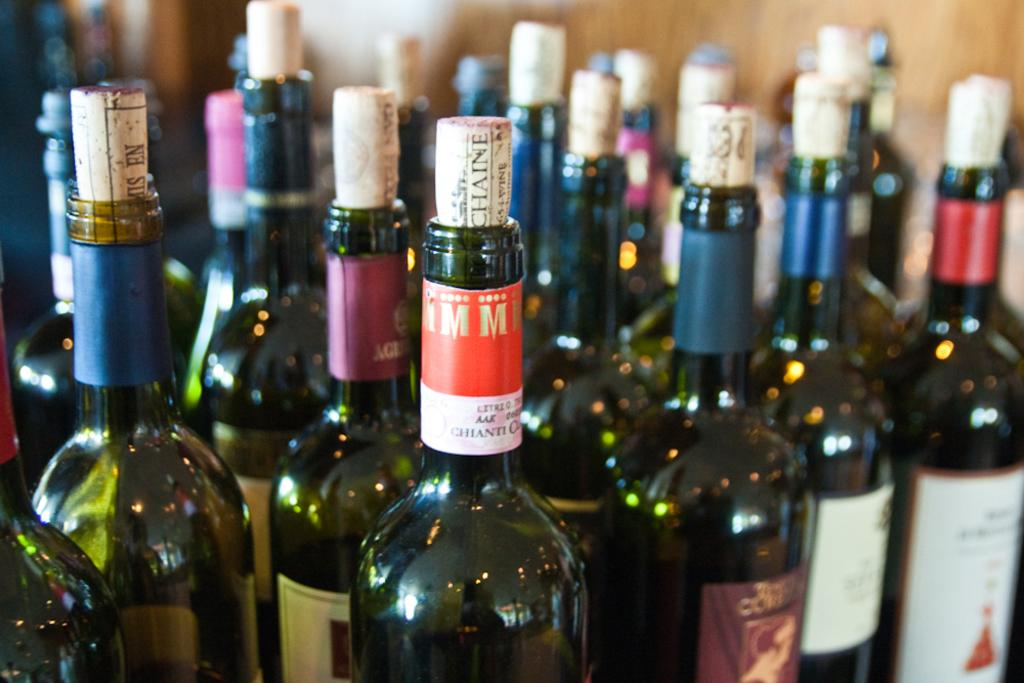<image>
Provide a brief description of the given image. Several corked bottles bundled together, including one bottle of Chianti. 